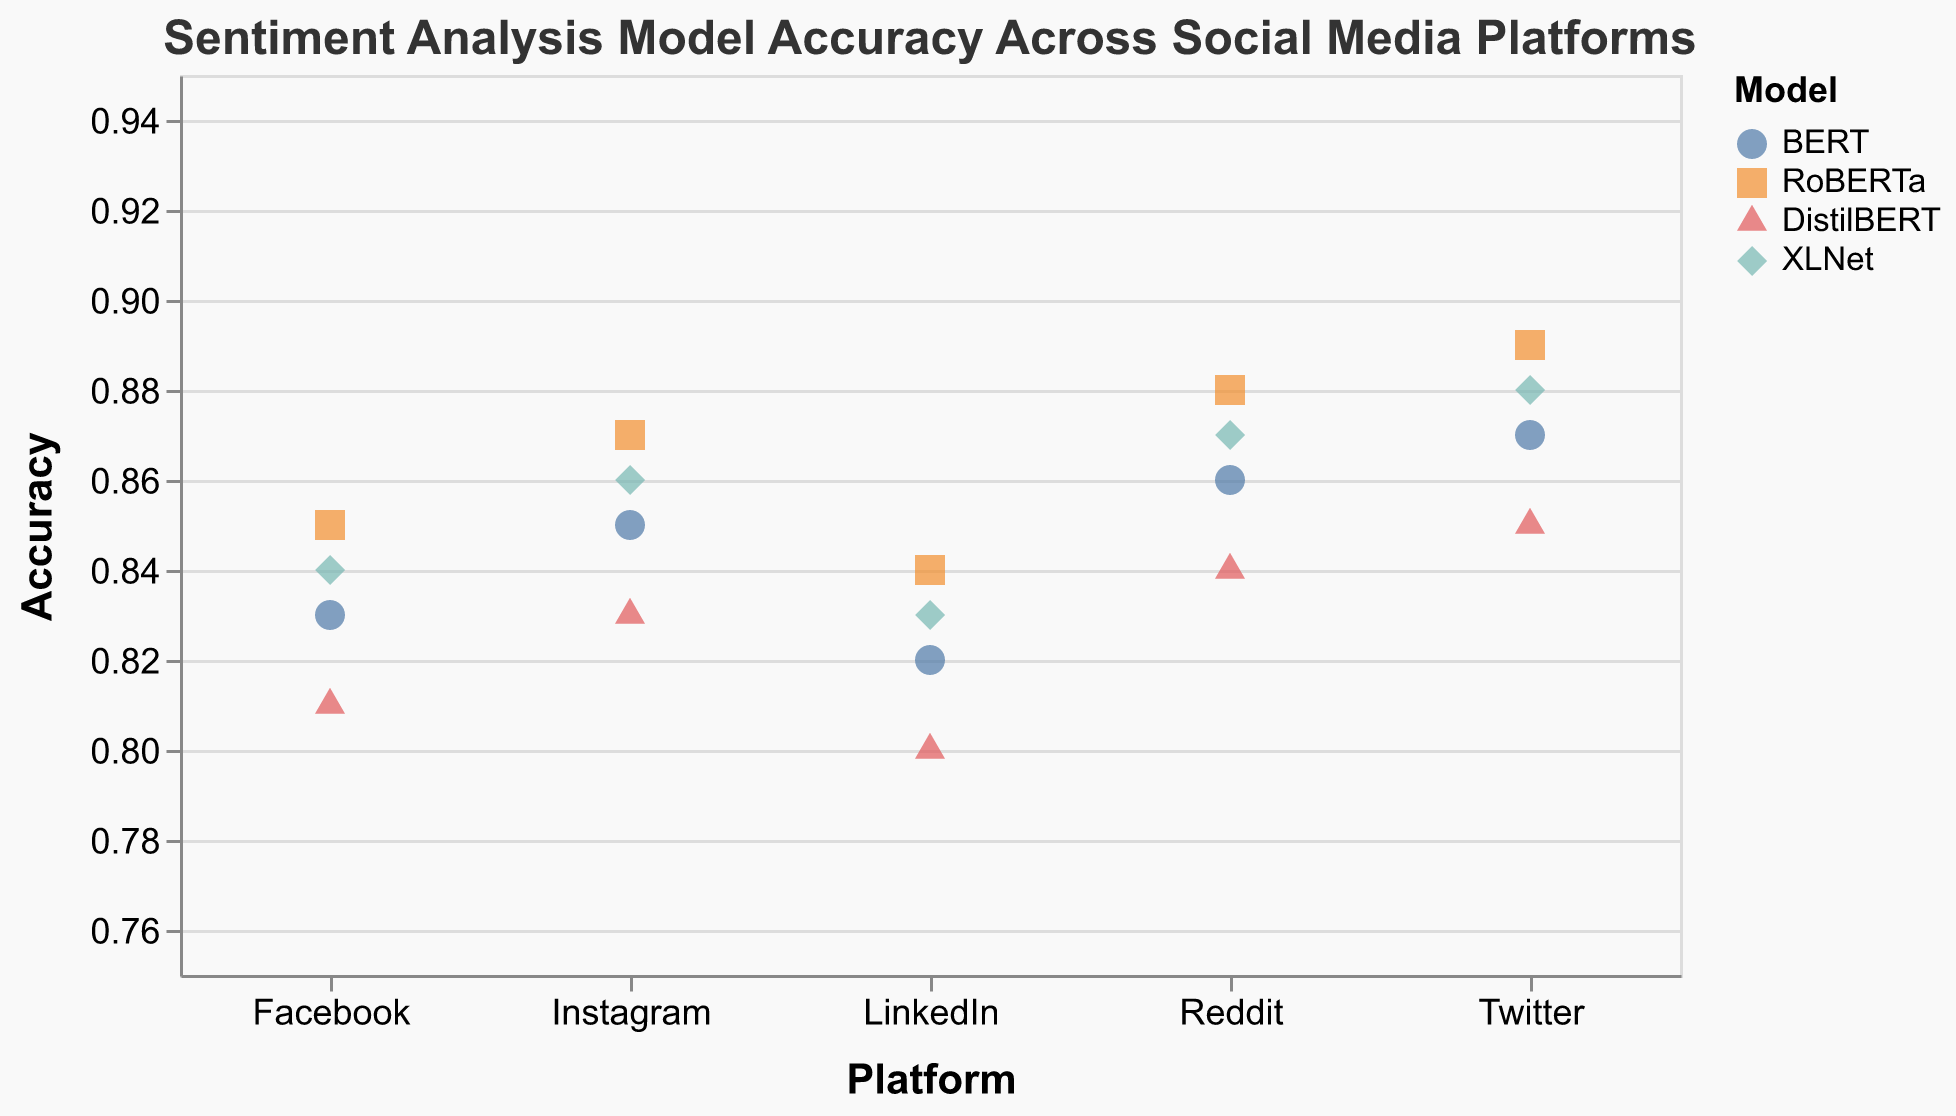What is the title of the plot? The title of the plot is usually displayed at the top of the figure. In this case, it reads "Sentiment Analysis Model Accuracy Across Social Media Platforms"
Answer: Sentiment Analysis Model Accuracy Across Social Media Platforms How many social media platforms are analyzed in this plot? The plot has the x-axis labeled with the platforms: Twitter, Facebook, Reddit, LinkedIn, and Instagram. Counting these labels gives us five platforms.
Answer: 5 What is the range of accuracy values shown on the y-axis? By looking at the y-axis, the scale is set to a range from 0.75 to 0.95
Answer: 0.75 to 0.95 Which model has the highest accuracy on Reddit? To find out which model has the highest accuracy on Reddit, we need to look at the data points for Reddit. The highest accuracy for Reddit is represented by RoBERTa with an accuracy of 0.88
Answer: RoBERTa What is the average accuracy of the models on the Facebook platform? To calculate the average accuracy of the models on Facebook, add the accuracy values for each model (BERT: 0.83, RoBERTa: 0.85, DistilBERT: 0.81, XLNet: 0.84) and divide by the number of models: (0.83 + 0.85 + 0.81 + 0.84) / 4 = 3.33 / 4 = 0.8325
Answer: 0.8325 Which platform has the lowest maximum accuracy among the models? To determine the platform with the lowest maximum accuracy, we need to compare the highest accuracy values on each platform. The highest values are: Twitter: 0.89, Facebook: 0.85, Reddit: 0.88, LinkedIn: 0.84, Instagram: 0.87. LinkedIn has the lowest maximum accuracy of 0.84
Answer: LinkedIn On which platform does BERT have the lowest accuracy? We need to find the accuracy values of BERT on all platforms and identify the lowest one: Twitter: 0.87, Facebook: 0.83, Reddit: 0.86, LinkedIn: 0.82, Instagram: 0.85. The lowest accuracy for BERT is on LinkedIn with 0.82
Answer: LinkedIn How does the accuracy of RoBERTa on Instagram compare with its accuracy on Twitter? To compare the accuracies, look at the accuracy of RoBERTa on Instagram (0.87) and Twitter (0.89). RoBERTa has a slightly higher accuracy on Twitter
Answer: Twitter > Instagram What is the combined accuracy of all models on the LinkedIn platform? To find the combined accuracy, sum the accuracies of each model on LinkedIn: BERT: 0.82, RoBERTa: 0.84, DistilBERT: 0.80, XLNet: 0.83. Combined accuracy is 0.82 + 0.84 + 0.80 + 0.83 = 3.29
Answer: 3.29 